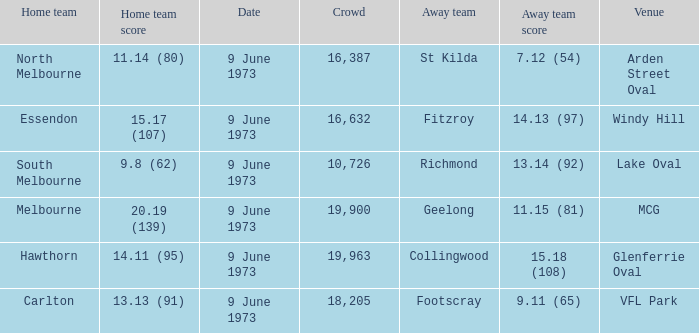What was North Melbourne's score as the home team? 11.14 (80). 